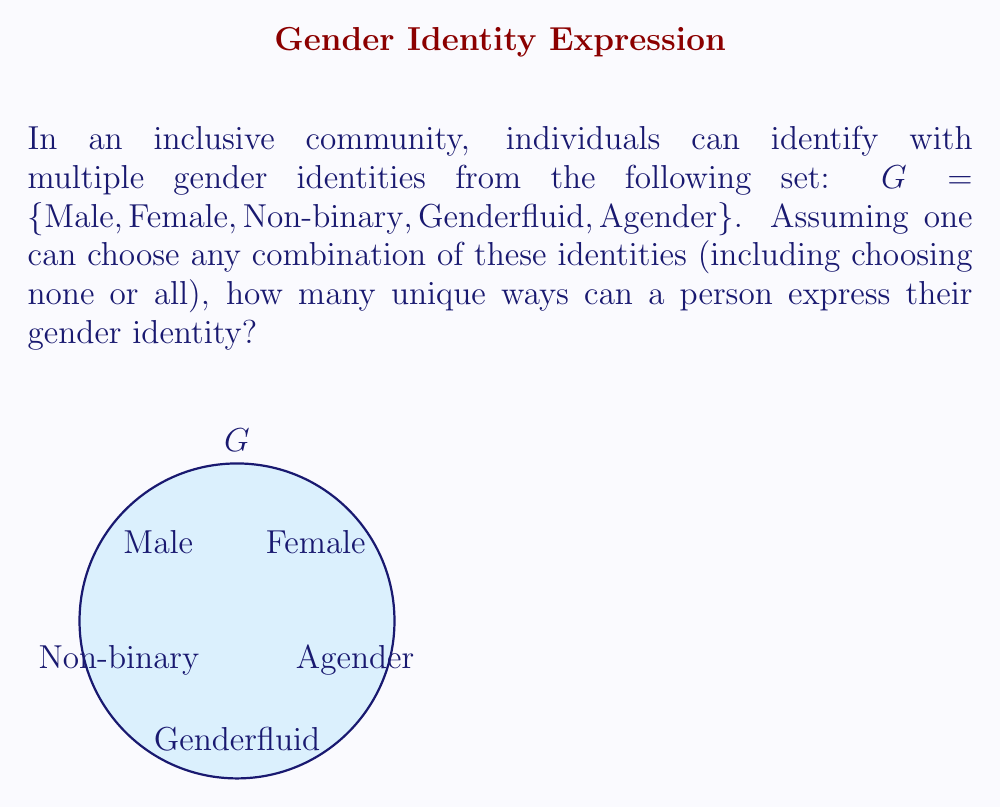What is the answer to this math problem? Let's approach this step-by-step using set theory:

1) We have a set $G$ with 5 elements.

2) For each element in the set, a person has two choices: include it in their identity or not.

3) This scenario is equivalent to finding the number of subsets of set $G$, including the empty set (choosing no identities) and the full set (choosing all identities).

4) In set theory, for a set with $n$ elements, the number of possible subsets is $2^n$. This is because for each element, we have 2 choices (include or not), and we make this choice independently for each of the $n$ elements.

5) In our case, $n = 5$ (the number of elements in set $G$).

6) Therefore, the number of possible gender identity combinations is:

   $$2^5 = 2 \times 2 \times 2 \times 2 \times 2 = 32$$

This result includes all possibilities: identifying with no genders, any single gender, any combination of genders, or all genders.
Answer: $32$ 